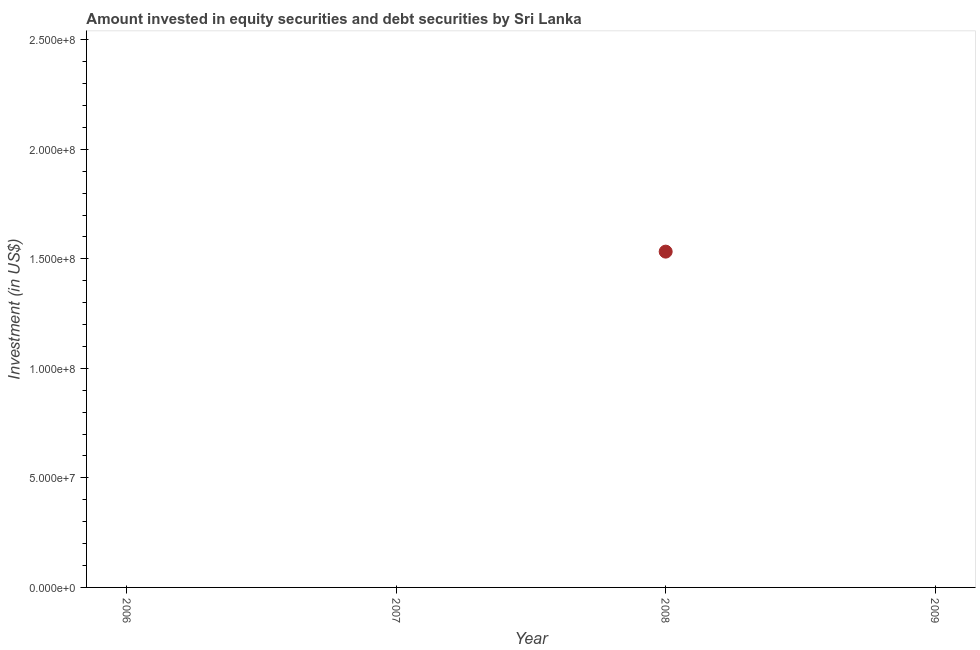Across all years, what is the maximum portfolio investment?
Give a very brief answer. 1.53e+08. In which year was the portfolio investment maximum?
Make the answer very short. 2008. What is the sum of the portfolio investment?
Provide a short and direct response. 1.53e+08. What is the average portfolio investment per year?
Ensure brevity in your answer.  3.83e+07. What is the difference between the highest and the lowest portfolio investment?
Offer a very short reply. 1.53e+08. In how many years, is the portfolio investment greater than the average portfolio investment taken over all years?
Keep it short and to the point. 1. Does the portfolio investment monotonically increase over the years?
Offer a very short reply. No. How many dotlines are there?
Keep it short and to the point. 1. How many years are there in the graph?
Ensure brevity in your answer.  4. What is the difference between two consecutive major ticks on the Y-axis?
Give a very brief answer. 5.00e+07. Are the values on the major ticks of Y-axis written in scientific E-notation?
Make the answer very short. Yes. Does the graph contain grids?
Offer a very short reply. No. What is the title of the graph?
Give a very brief answer. Amount invested in equity securities and debt securities by Sri Lanka. What is the label or title of the Y-axis?
Make the answer very short. Investment (in US$). What is the Investment (in US$) in 2006?
Give a very brief answer. 0. What is the Investment (in US$) in 2008?
Your answer should be very brief. 1.53e+08. What is the Investment (in US$) in 2009?
Ensure brevity in your answer.  0. 